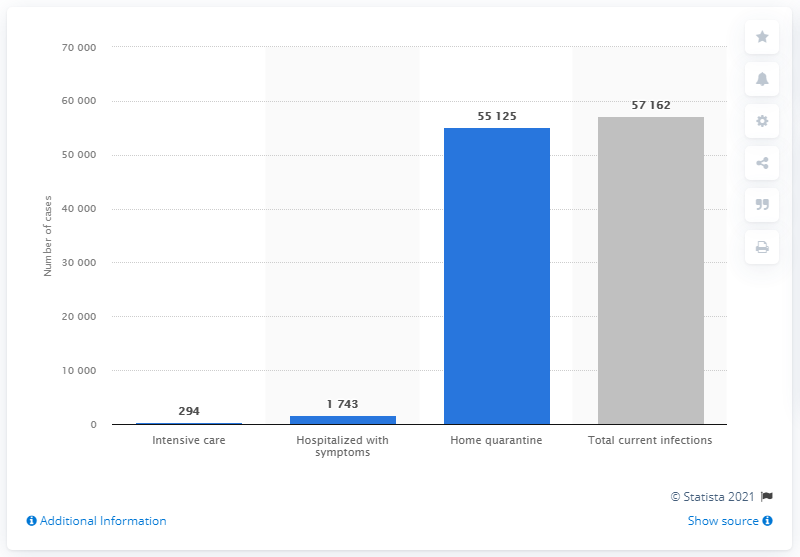Indicate a few pertinent items in this graphic. There were 294 individuals who were infected and being treated in intensive care units. 